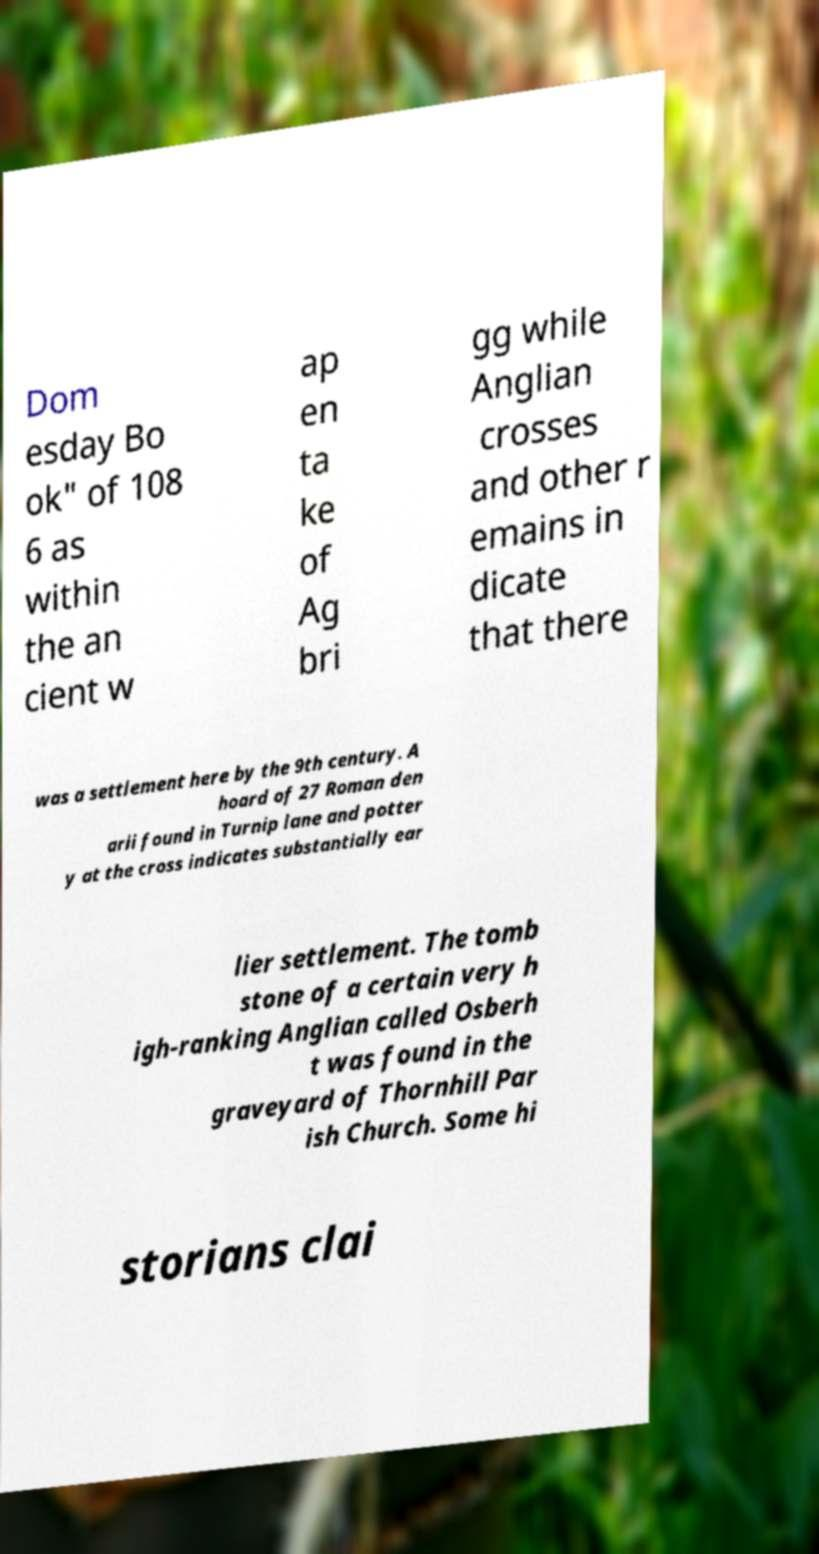There's text embedded in this image that I need extracted. Can you transcribe it verbatim? Dom esday Bo ok" of 108 6 as within the an cient w ap en ta ke of Ag bri gg while Anglian crosses and other r emains in dicate that there was a settlement here by the 9th century. A hoard of 27 Roman den arii found in Turnip lane and potter y at the cross indicates substantially ear lier settlement. The tomb stone of a certain very h igh-ranking Anglian called Osberh t was found in the graveyard of Thornhill Par ish Church. Some hi storians clai 